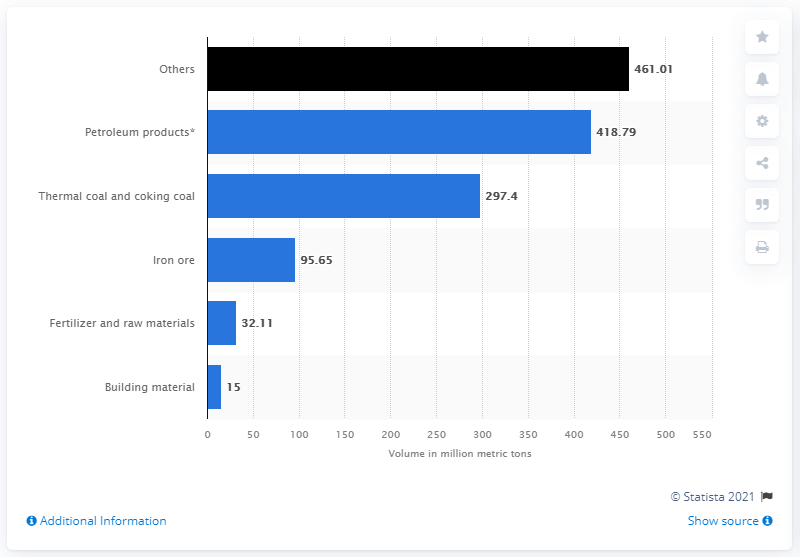Mention a couple of crucial points in this snapshot. In the fiscal year 2018, a total of 418.79 million metric tons of petroleum products were handled at Indian ports. 